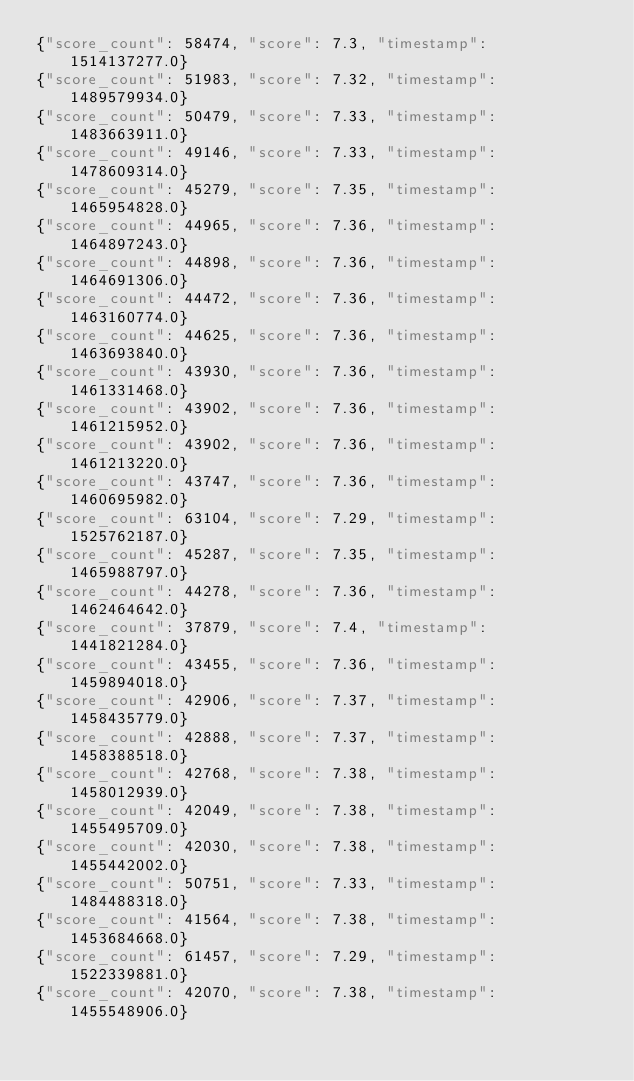Convert code to text. <code><loc_0><loc_0><loc_500><loc_500><_Julia_>{"score_count": 58474, "score": 7.3, "timestamp": 1514137277.0}
{"score_count": 51983, "score": 7.32, "timestamp": 1489579934.0}
{"score_count": 50479, "score": 7.33, "timestamp": 1483663911.0}
{"score_count": 49146, "score": 7.33, "timestamp": 1478609314.0}
{"score_count": 45279, "score": 7.35, "timestamp": 1465954828.0}
{"score_count": 44965, "score": 7.36, "timestamp": 1464897243.0}
{"score_count": 44898, "score": 7.36, "timestamp": 1464691306.0}
{"score_count": 44472, "score": 7.36, "timestamp": 1463160774.0}
{"score_count": 44625, "score": 7.36, "timestamp": 1463693840.0}
{"score_count": 43930, "score": 7.36, "timestamp": 1461331468.0}
{"score_count": 43902, "score": 7.36, "timestamp": 1461215952.0}
{"score_count": 43902, "score": 7.36, "timestamp": 1461213220.0}
{"score_count": 43747, "score": 7.36, "timestamp": 1460695982.0}
{"score_count": 63104, "score": 7.29, "timestamp": 1525762187.0}
{"score_count": 45287, "score": 7.35, "timestamp": 1465988797.0}
{"score_count": 44278, "score": 7.36, "timestamp": 1462464642.0}
{"score_count": 37879, "score": 7.4, "timestamp": 1441821284.0}
{"score_count": 43455, "score": 7.36, "timestamp": 1459894018.0}
{"score_count": 42906, "score": 7.37, "timestamp": 1458435779.0}
{"score_count": 42888, "score": 7.37, "timestamp": 1458388518.0}
{"score_count": 42768, "score": 7.38, "timestamp": 1458012939.0}
{"score_count": 42049, "score": 7.38, "timestamp": 1455495709.0}
{"score_count": 42030, "score": 7.38, "timestamp": 1455442002.0}
{"score_count": 50751, "score": 7.33, "timestamp": 1484488318.0}
{"score_count": 41564, "score": 7.38, "timestamp": 1453684668.0}
{"score_count": 61457, "score": 7.29, "timestamp": 1522339881.0}
{"score_count": 42070, "score": 7.38, "timestamp": 1455548906.0}
</code> 